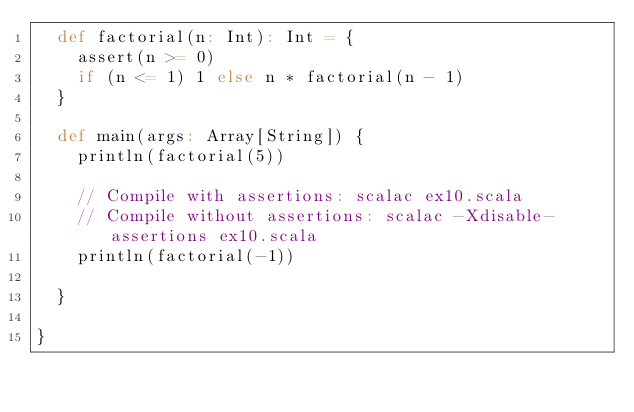<code> <loc_0><loc_0><loc_500><loc_500><_Scala_>  def factorial(n: Int): Int = {
    assert(n >= 0)
    if (n <= 1) 1 else n * factorial(n - 1)
  }

  def main(args: Array[String]) {
    println(factorial(5))

    // Compile with assertions: scalac ex10.scala
    // Compile without assertions: scalac -Xdisable-assertions ex10.scala
    println(factorial(-1))

  }

}</code> 